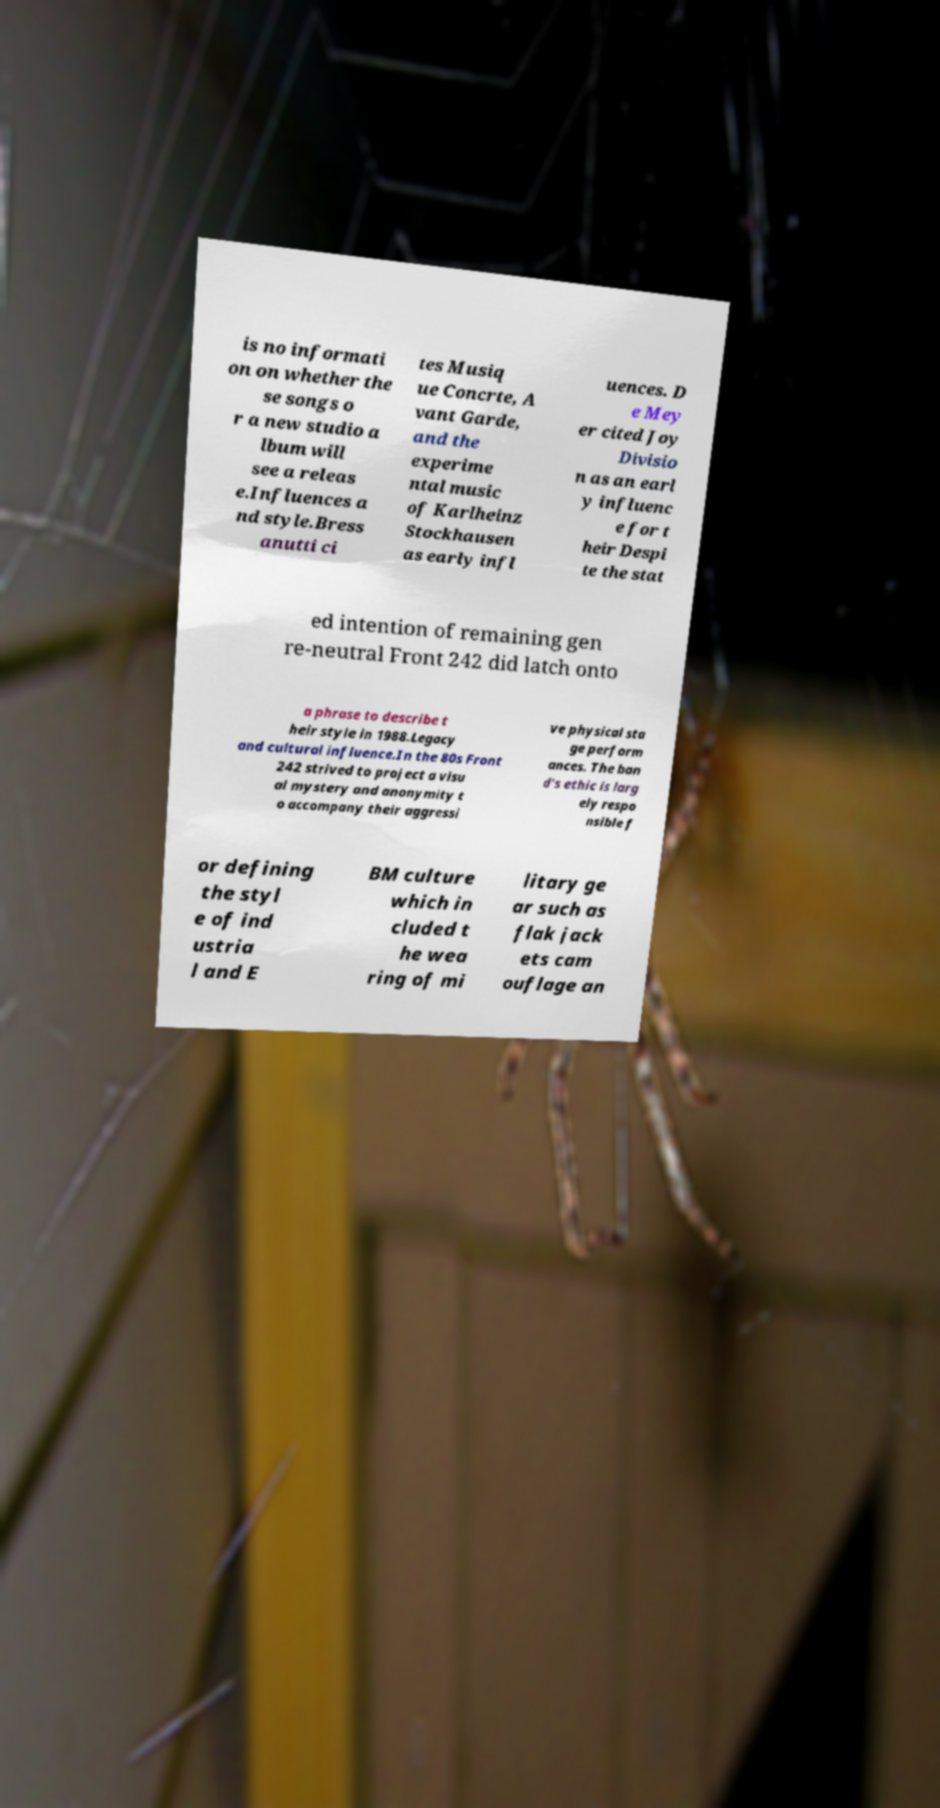Can you accurately transcribe the text from the provided image for me? is no informati on on whether the se songs o r a new studio a lbum will see a releas e.Influences a nd style.Bress anutti ci tes Musiq ue Concrte, A vant Garde, and the experime ntal music of Karlheinz Stockhausen as early infl uences. D e Mey er cited Joy Divisio n as an earl y influenc e for t heir Despi te the stat ed intention of remaining gen re-neutral Front 242 did latch onto a phrase to describe t heir style in 1988.Legacy and cultural influence.In the 80s Front 242 strived to project a visu al mystery and anonymity t o accompany their aggressi ve physical sta ge perform ances. The ban d's ethic is larg ely respo nsible f or defining the styl e of ind ustria l and E BM culture which in cluded t he wea ring of mi litary ge ar such as flak jack ets cam ouflage an 